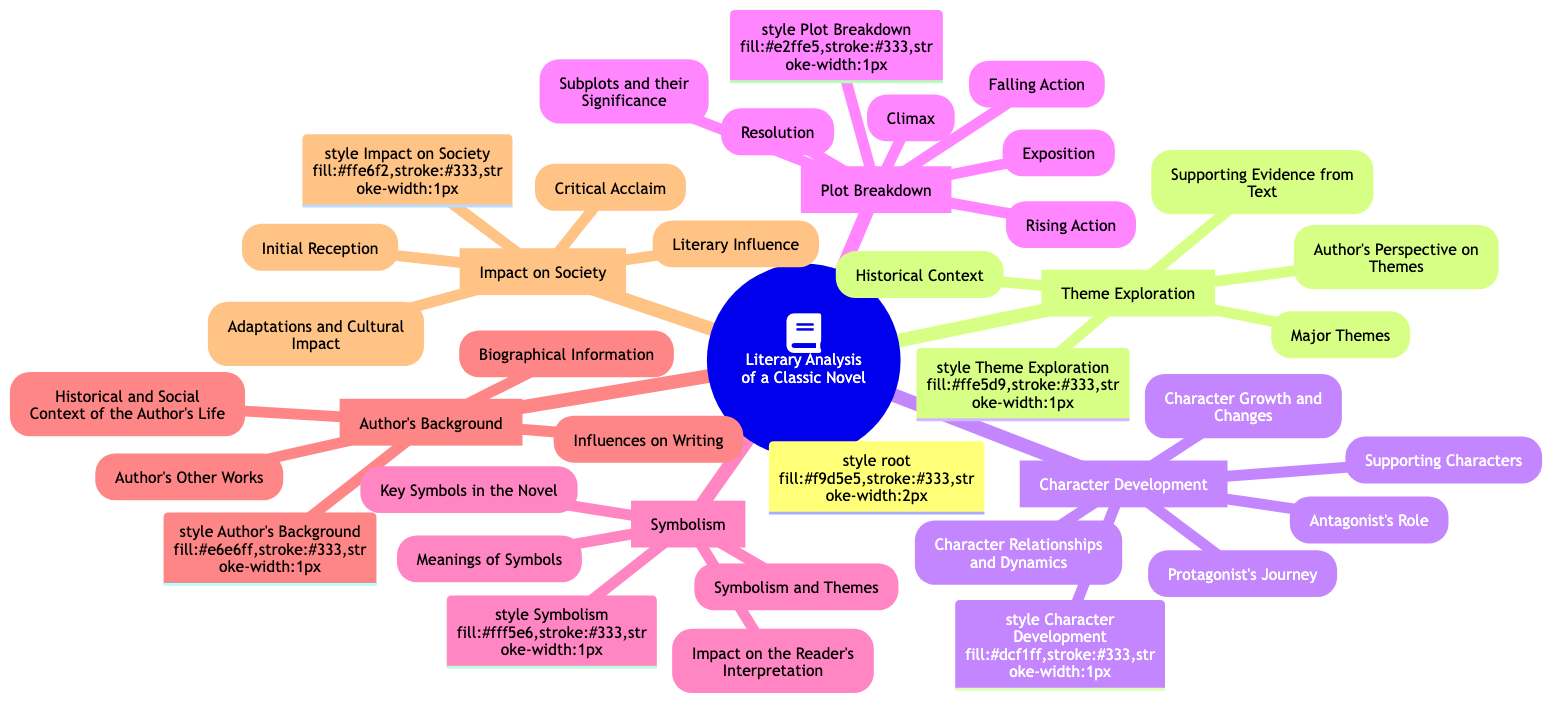What are the main sections of the mind map? The main sections of the mind map are Theme Exploration, Character Development, Plot Breakdown, Symbolism, Author's Background, and Impact on Society. Each of these sections represents a key aspect of literary analysis related to a classic novel.
Answer: Theme Exploration, Character Development, Plot Breakdown, Symbolism, Author's Background, Impact on Society How many subtopics are listed under Character Development? Under Character Development, there are five subtopics: Protagonist's Journey, Antagonist's Role, Supporting Characters, Character Relationships and Dynamics, and Character Growth and Changes. The count is derived by simply enumerating the listed subtopics.
Answer: 5 Which section includes "Key Symbols in the Novel"? "Key Symbols in the Novel" is found under the section Symbolism. The title indicates that it focuses on the significant symbols that are present in the novel, as per the structure outlined in the mind map.
Answer: Symbolism What is the relationship between Symbolism and Themes? The relationship between Symbolism and Themes is that they interact, as indicated in the mind map. The symbolism in a novel often connects to the themes, enriching the reader's understanding of both elements.
Answer: Symbolism and Themes Which author-related aspect includes historical context? The aspect that includes historical context is Author's Background, which encompasses Biographical Information, Author's Other Works, Influences on Writing, and Historical and Social Context of the Author’s Life, covering the author's influences.
Answer: Author's Background What section would you explore for Initial Reception of a novel? For the Initial Reception of a novel, you would explore the Impact on Society section. This section addresses how the novel was perceived at its inception among critics and readers alike.
Answer: Impact on Society How many key elements are in the Plot Breakdown? There are six key elements in the Plot Breakdown: Exposition, Rising Action, Climax, Falling Action, Resolution, and Subplots and their Significance. This is determined by counting each listed component in that section.
Answer: 6 What do the supporting evidence and historical context relate to? Supporting evidence and historical context relate to Theme Exploration, as they provide necessary background and text examples to understand the themes more deeply within the narrative.
Answer: Theme Exploration Which section of the mind map covers Adaptations and Cultural Impact? The section that covers Adaptations and Cultural Impact is Impact on Society. This part reflects on how the novel influences culture, including adaptations in various forms such as films or plays.
Answer: Impact on Society 